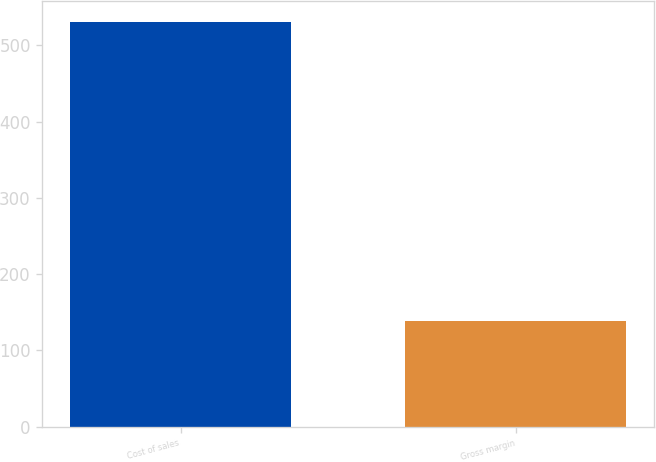<chart> <loc_0><loc_0><loc_500><loc_500><bar_chart><fcel>Cost of sales<fcel>Gross margin<nl><fcel>531<fcel>139<nl></chart> 